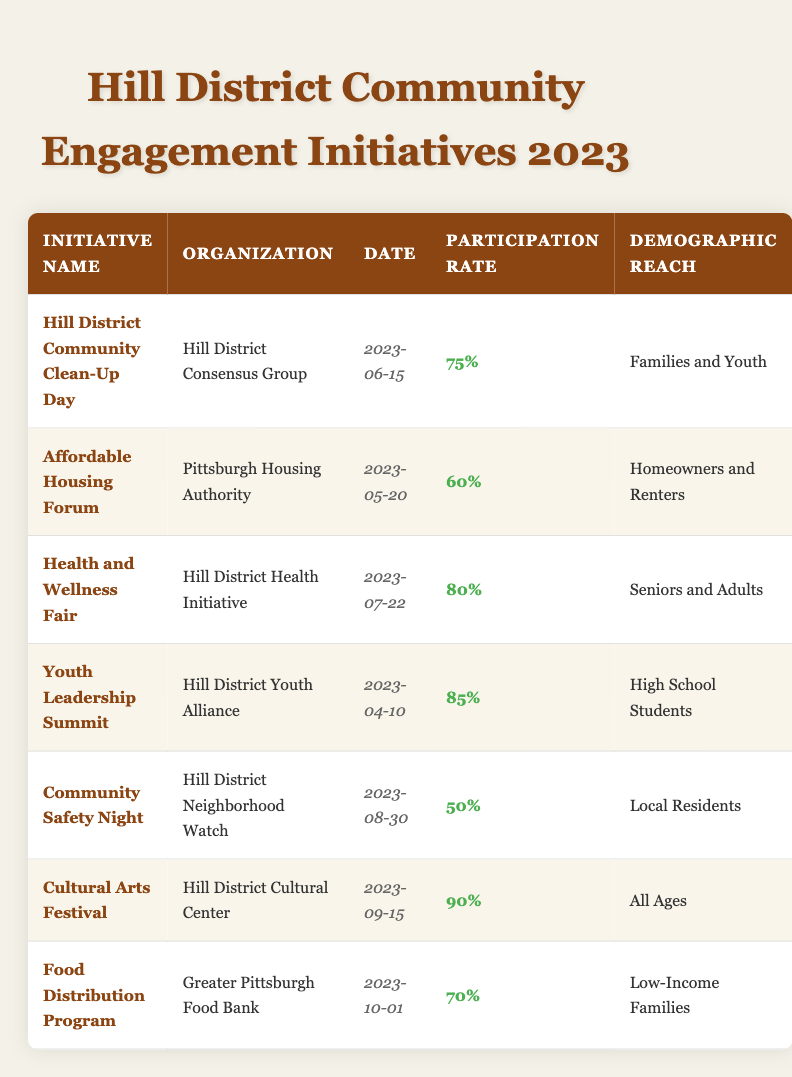What is the participation rate for the "Cultural Arts Festival"? The "Cultural Arts Festival" has a participation rate listed in the table as "90%".
Answer: 90% Who organized the "Youth Leadership Summit"? The "Youth Leadership Summit" is organized by the "Hill District Youth Alliance" as shown in the table.
Answer: Hill District Youth Alliance Which initiative had the highest participation rate? The table indicates that the "Cultural Arts Festival" had the highest participation rate at "90%".
Answer: Cultural Arts Festival What demographic was reached by the "Health and Wellness Fair"? According to the table, the "Health and Wellness Fair" reached "Seniors and Adults".
Answer: Seniors and Adults Calculate the average participation rate of all initiatives listed. The participation rates are 75%, 60%, 80%, 85%, 50%, 90%, and 70%. First, sum these rates: 75 + 60 + 80 + 85 + 50 + 90 + 70 = 510. Since there are 7 initiatives, the average is 510 / 7 = 72.86.
Answer: 72.86% True or False: The "Community Safety Night" had a participation rate higher than 60%. The "Community Safety Night" has a participation rate of "50%", which is lower than 60%. Therefore, the statement is false.
Answer: False How many initiatives are aimed at families and youth? The table shows two initiatives aimed at families and youth: "Hill District Community Clean-Up Day" and "Food Distribution Program".
Answer: Two Which organization hosted the initiative with the lowest participation rate? The initiative with the lowest participation rate is "Community Safety Night" at "50%", organized by the "Hill District Neighborhood Watch".
Answer: Hill District Neighborhood Watch What was the date of the "Affordable Housing Forum"? The date for the "Affordable Housing Forum" is listed as "2023-05-20" in the table.
Answer: 2023-05-20 If you exclude initiatives aimed at seniors and adults, what is the average participation rate? The relevant initiatives are: "Hill District Community Clean-Up Day" (75%), "Affordable Housing Forum" (60%), "Youth Leadership Summit" (85%), "Community Safety Night" (50%), "Cultural Arts Festival" (90%), and "Food Distribution Program" (70%). Sum: 75 + 60 + 85 + 50 + 90 + 70 = 430. With 6 initiatives, the average is 430 / 6 = 71.67.
Answer: 71.67% 